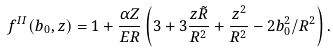<formula> <loc_0><loc_0><loc_500><loc_500>f ^ { I I } ( b _ { 0 } , z ) = 1 + \frac { \alpha Z } { E R } \left ( 3 + 3 \frac { z \tilde { R } } { R ^ { 2 } } + \frac { z ^ { 2 } } { R ^ { 2 } } - 2 b _ { 0 } ^ { 2 } / R ^ { 2 } \right ) .</formula> 